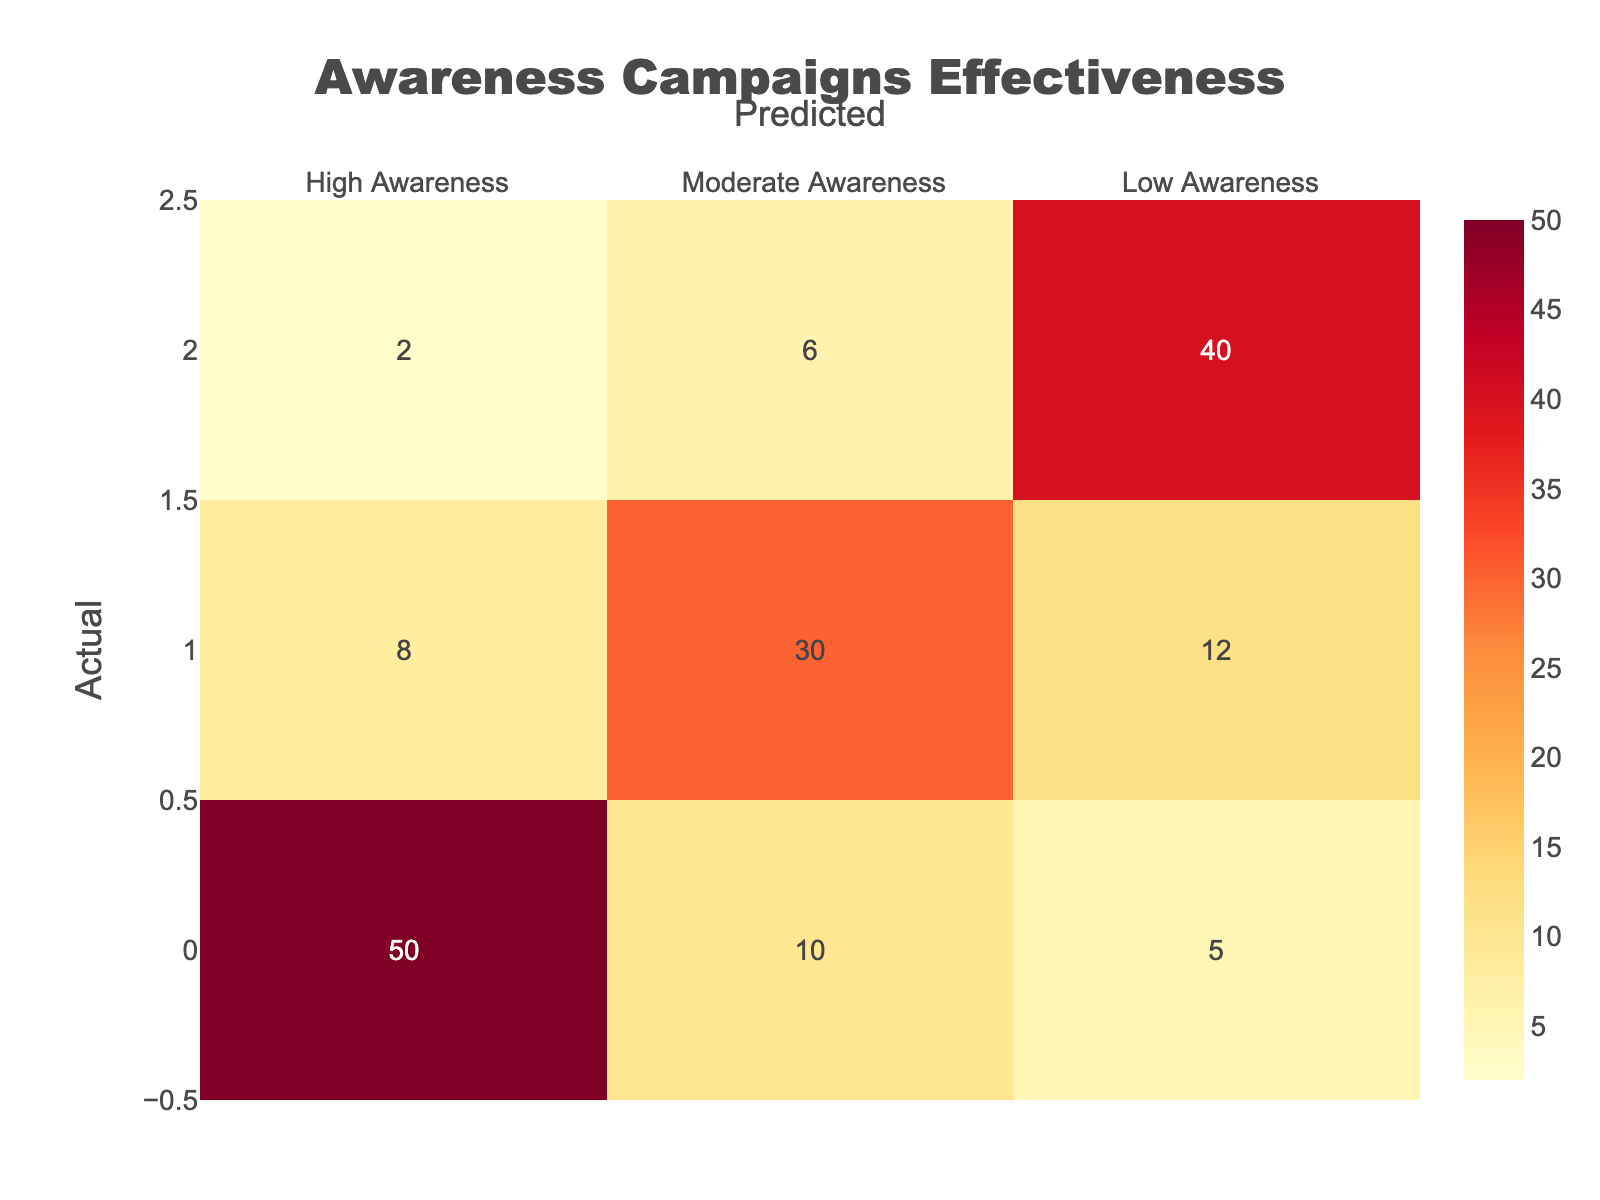What is the number of campaigns that led to a prediction of High Awareness when the actual awareness was High? From the table, in the "High Awareness" row under the "High Awareness" column, the value is 50. This indicates that 50 campaigns were correctly predicted as having high awareness when they actually did.
Answer: 50 How many campaigns were incorrectly predicted as Low Awareness when the actual awareness was Moderate? In the "Moderate Awareness" row under the "Low Awareness" column, the table shows the value of 12. Thus, 12 campaigns were misclassified as having low awareness despite their actual moderate awareness.
Answer: 12 What is the total number of campaigns that predicted Moderate Awareness? To find the total, we sum the values in the "Moderate Awareness" column: (10 + 30 + 6) = 46. Therefore, the total number of campaigns that predicted moderate awareness is 46.
Answer: 46 True or False: More campaigns were predicted to have High Awareness than were actually at Low Awareness. The number of campaigns predicted as High Awareness is found by summing the values in the "High Awareness" column: (50 + 8 + 2) = 60. The number of campaigns that were actually Low Awareness is 40. Since 60 > 40, this statement is True.
Answer: True What percentage of campaigns that were actually at High Awareness were predicted correctly as High Awareness? To calculate this percentage, use the formula (correct predictions/total actual) * 100. Here, correct predictions = 50 and total actual = (50 + 10 + 5) = 65. Thus, (50/65) * 100 ≈ 76.92%. Therefore, approximately 76.92% were correctly predicted.
Answer: 76.92% What is the difference between the number of campaigns that predicted Low Awareness and those that predicted High Awareness? The number of campaigns predicted as Low Awareness is found by summing the values in the "Low Awareness" column: (5 + 12 + 40) = 57. For High Awareness, the total is (50 + 10 + 2) = 62. The difference is 62 - 57 = 5, indicating that more campaigns predicted High Awareness.
Answer: 5 How many campaigns had a prediction of Moderate Awareness while the actual awareness was Low? From the table, in the "Low Awareness" row and "Moderate Awareness" column, the value is 6. This means that 6 campaigns were incorrectly predicted as having moderate awareness when they actually had low awareness.
Answer: 6 True or False: The number of campaigns that achieved High Awareness is greater than the number of campaigns with Low Awareness. From the data, campaigns with High Awareness (50 + 10 + 5 = 65) versus Low Awareness (2 + 6 + 40 = 48). Since 65 > 48, this statement is True.
Answer: True What is the average number of campaigns for each level of awareness predicted? Sum the values for High Awareness: 50 + 10 + 5 = 65, for Moderate Awareness: 8 + 30 + 12 = 50, and for Low Awareness: 2 + 6 + 40 = 48. Average for each level: High = 65/3 ≈ 21.67, Moderate = 50/3 ≈ 16.67, Low = 48/3 = 16. Average counts are, for High awareness ≈ 21.67, Moderate awareness ≈ 16.67, and Low awareness = 16.
Answer: High: 21.67, Moderate: 16.67, Low: 16 